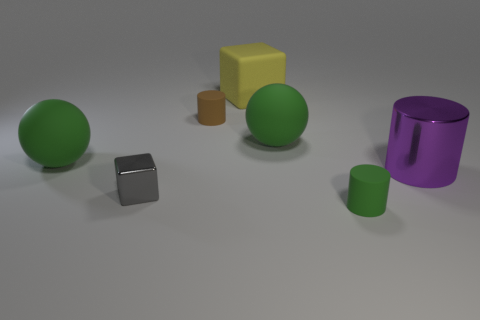Describe the texture of the objects. Are they all the same? The textures of the objects are not uniform. The large purple and small green cylinders have a metallic sheen indicating a smooth and reflective surface. The spheres and cubes, on the other hand, appear to have a matte finish, suggesting a non-reflective, possibly rougher texture. 